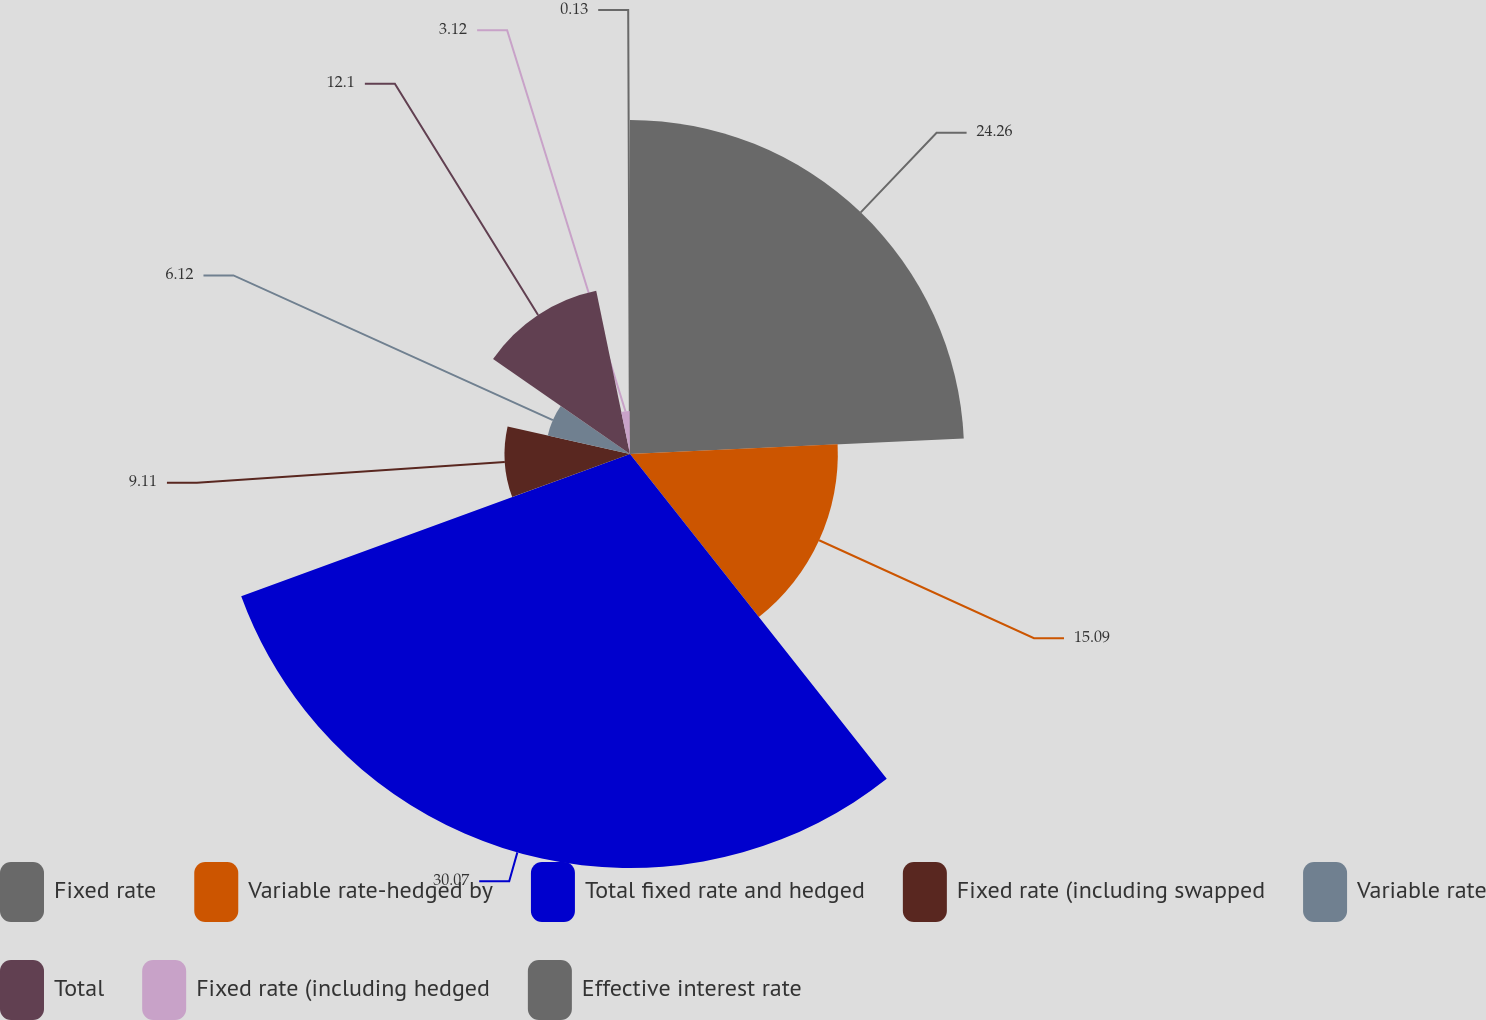<chart> <loc_0><loc_0><loc_500><loc_500><pie_chart><fcel>Fixed rate<fcel>Variable rate-hedged by<fcel>Total fixed rate and hedged<fcel>Fixed rate (including swapped<fcel>Variable rate<fcel>Total<fcel>Fixed rate (including hedged<fcel>Effective interest rate<nl><fcel>24.26%<fcel>15.09%<fcel>30.06%<fcel>9.11%<fcel>6.12%<fcel>12.1%<fcel>3.12%<fcel>0.13%<nl></chart> 